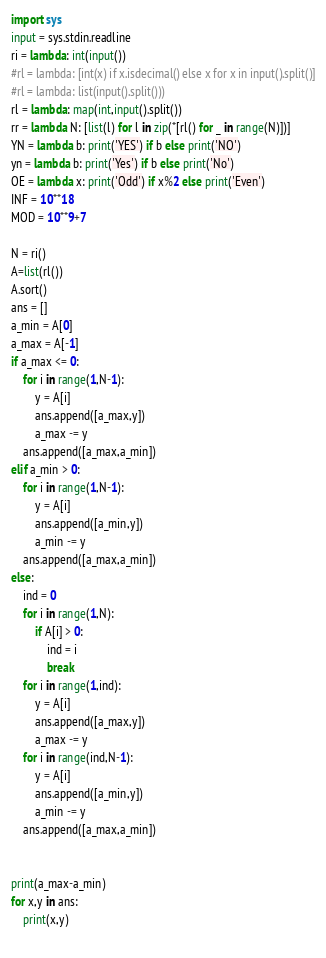<code> <loc_0><loc_0><loc_500><loc_500><_Python_>import sys
input = sys.stdin.readline
ri = lambda: int(input())
#rl = lambda: [int(x) if x.isdecimal() else x for x in input().split()]
#rl = lambda: list(input().split()))
rl = lambda: map(int,input().split())
rr = lambda N: [list(l) for l in zip(*[rl() for _ in range(N)])]
YN = lambda b: print('YES') if b else print('NO')
yn = lambda b: print('Yes') if b else print('No')
OE = lambda x: print('Odd') if x%2 else print('Even')
INF = 10**18
MOD = 10**9+7

N = ri()
A=list(rl())
A.sort()
ans = []
a_min = A[0]
a_max = A[-1]
if a_max <= 0:
    for i in range(1,N-1):
        y = A[i]
        ans.append([a_max,y])
        a_max -= y
    ans.append([a_max,a_min])
elif a_min > 0:
    for i in range(1,N-1):
        y = A[i]
        ans.append([a_min,y])
        a_min -= y
    ans.append([a_max,a_min])
else:
    ind = 0
    for i in range(1,N):
        if A[i] > 0:
            ind = i
            break
    for i in range(1,ind):
        y = A[i]
        ans.append([a_max,y])
        a_max -= y
    for i in range(ind,N-1):
        y = A[i]
        ans.append([a_min,y])
        a_min -= y
    ans.append([a_max,a_min])


print(a_max-a_min)
for x,y in ans:
    print(x,y)
        </code> 